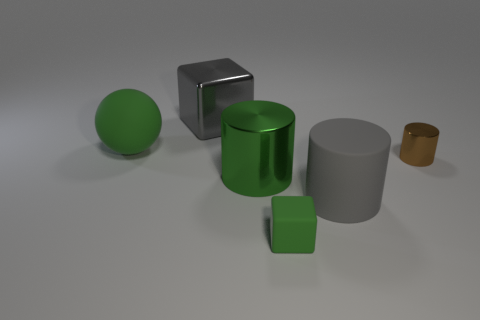Add 4 large rubber cubes. How many objects exist? 10 Subtract all cubes. How many objects are left? 4 Subtract all big green metal things. Subtract all cylinders. How many objects are left? 2 Add 4 green matte balls. How many green matte balls are left? 5 Add 2 small gray cylinders. How many small gray cylinders exist? 2 Subtract 0 cyan balls. How many objects are left? 6 